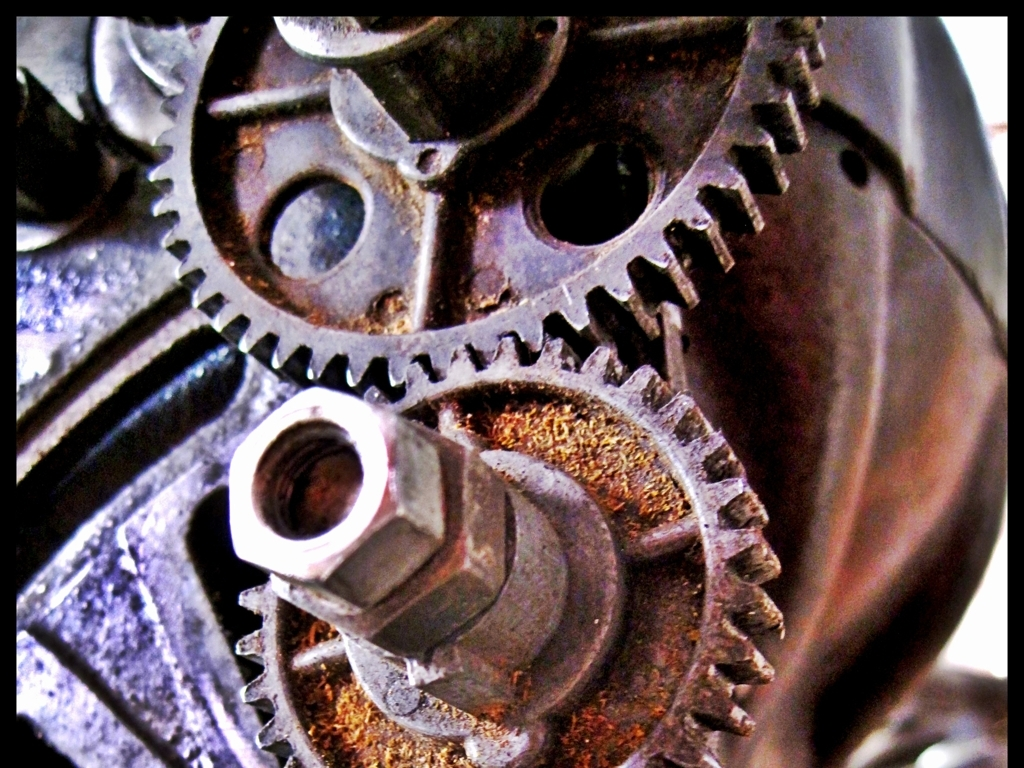Can you tell me about the condition of these gears? The gears show signs of wear and oxidation. The rusty surface suggests they have been exposed to moisture or corrosive elements. Despite this, the gears' teeth are still well-defined, indicating they may still be functional although likely not operating at optimal efficiency. 